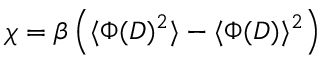Convert formula to latex. <formula><loc_0><loc_0><loc_500><loc_500>\chi = \beta \left ( \langle \Phi ( D ) ^ { 2 } \rangle - \langle \Phi ( D ) \rangle ^ { 2 } \right )</formula> 